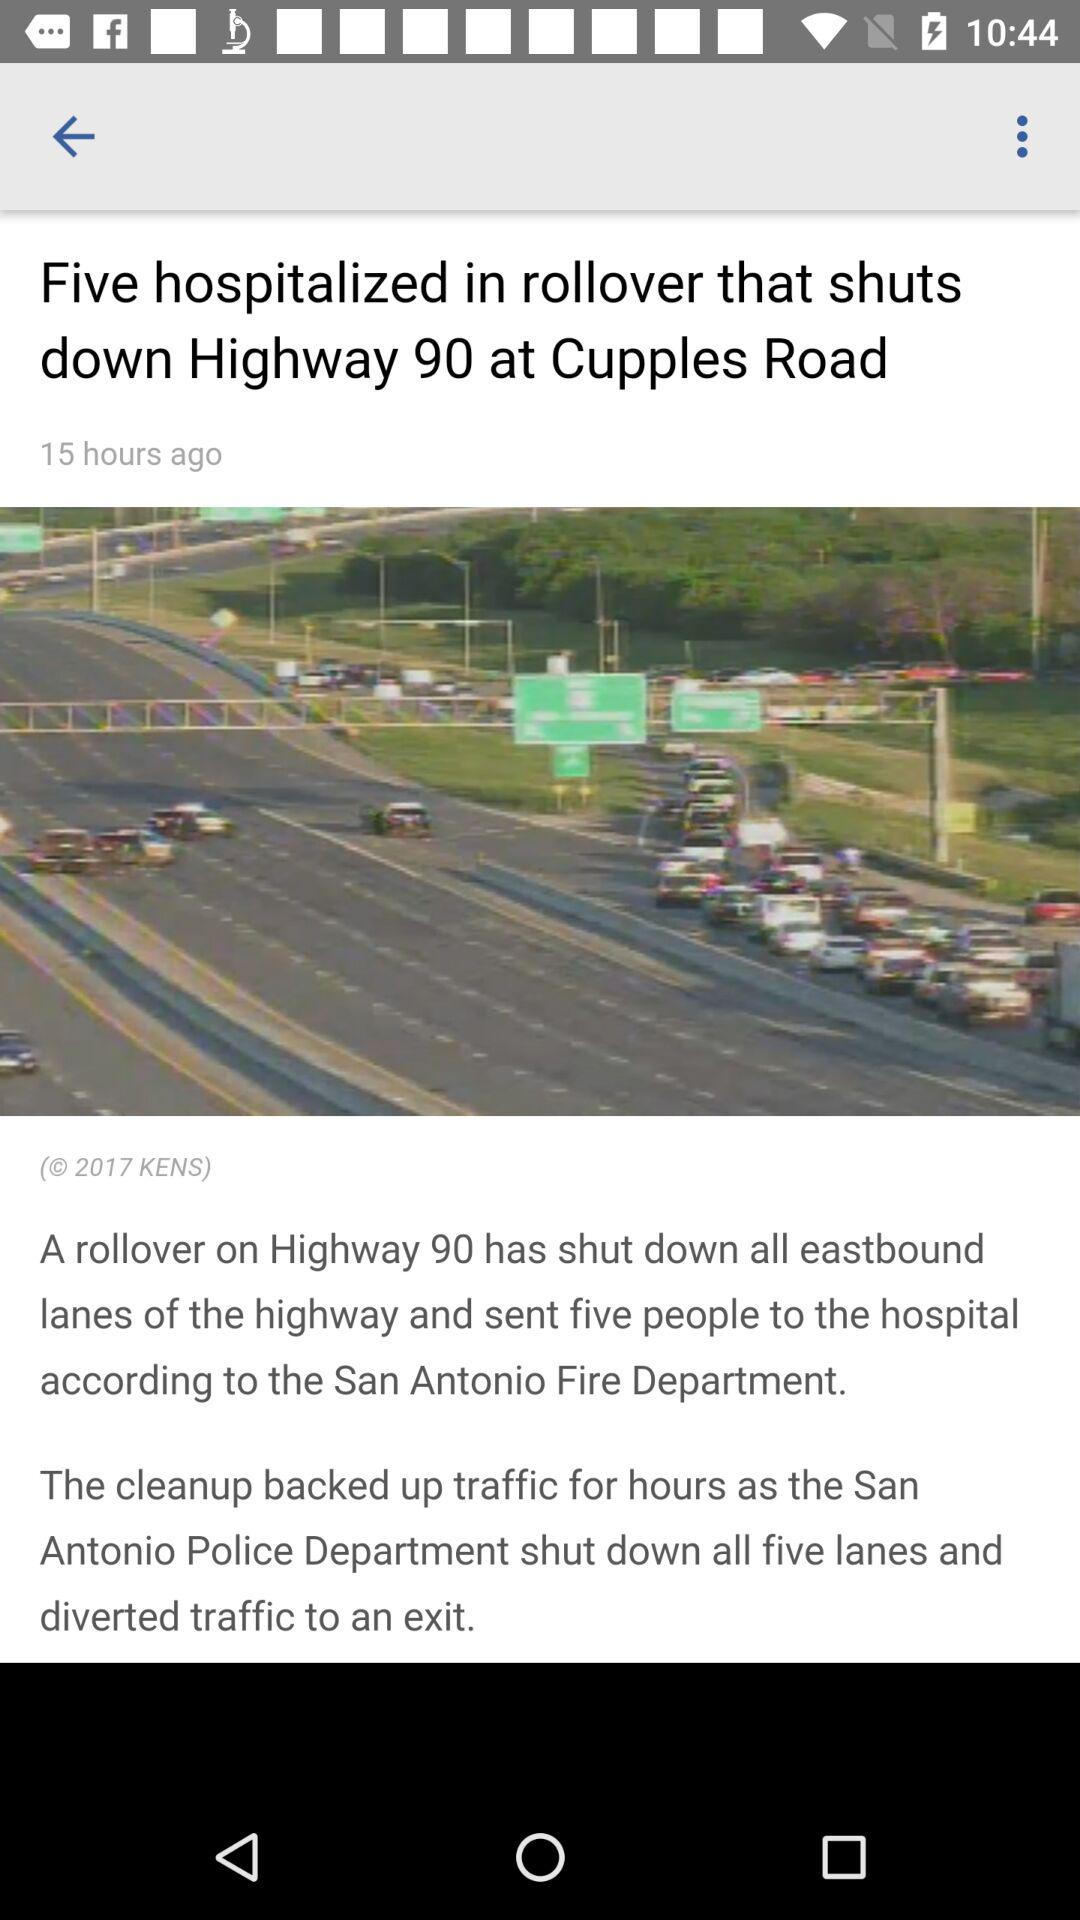How many lanes are shut down by the San Antonio Police Department? The San Antonio Police Department shut down five lanes. 